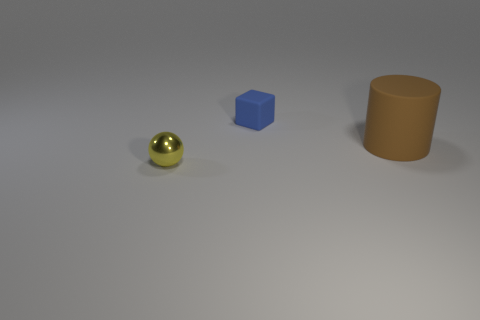Is there another big brown cylinder that has the same material as the large brown cylinder?
Give a very brief answer. No. What shape is the tiny blue matte thing?
Offer a very short reply. Cube. How many tiny yellow shiny things are there?
Keep it short and to the point. 1. The metal object in front of the matte thing in front of the blue matte object is what color?
Make the answer very short. Yellow. What is the color of the sphere that is the same size as the block?
Make the answer very short. Yellow. Are there any cubes of the same color as the large thing?
Your response must be concise. No. Are any small brown rubber spheres visible?
Your answer should be very brief. No. What is the shape of the small object behind the yellow object?
Keep it short and to the point. Cube. What number of objects are in front of the rubber block and to the right of the yellow sphere?
Ensure brevity in your answer.  1. What number of other things are the same size as the rubber cylinder?
Your response must be concise. 0. 